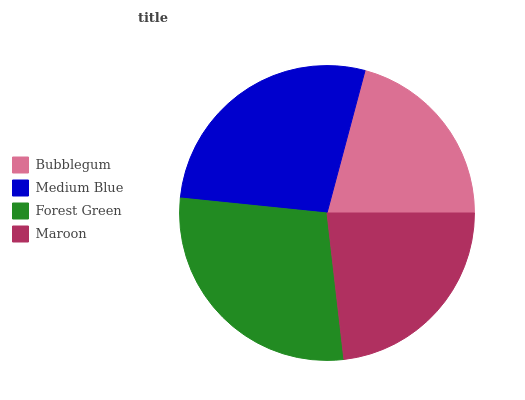Is Bubblegum the minimum?
Answer yes or no. Yes. Is Forest Green the maximum?
Answer yes or no. Yes. Is Medium Blue the minimum?
Answer yes or no. No. Is Medium Blue the maximum?
Answer yes or no. No. Is Medium Blue greater than Bubblegum?
Answer yes or no. Yes. Is Bubblegum less than Medium Blue?
Answer yes or no. Yes. Is Bubblegum greater than Medium Blue?
Answer yes or no. No. Is Medium Blue less than Bubblegum?
Answer yes or no. No. Is Medium Blue the high median?
Answer yes or no. Yes. Is Maroon the low median?
Answer yes or no. Yes. Is Maroon the high median?
Answer yes or no. No. Is Bubblegum the low median?
Answer yes or no. No. 